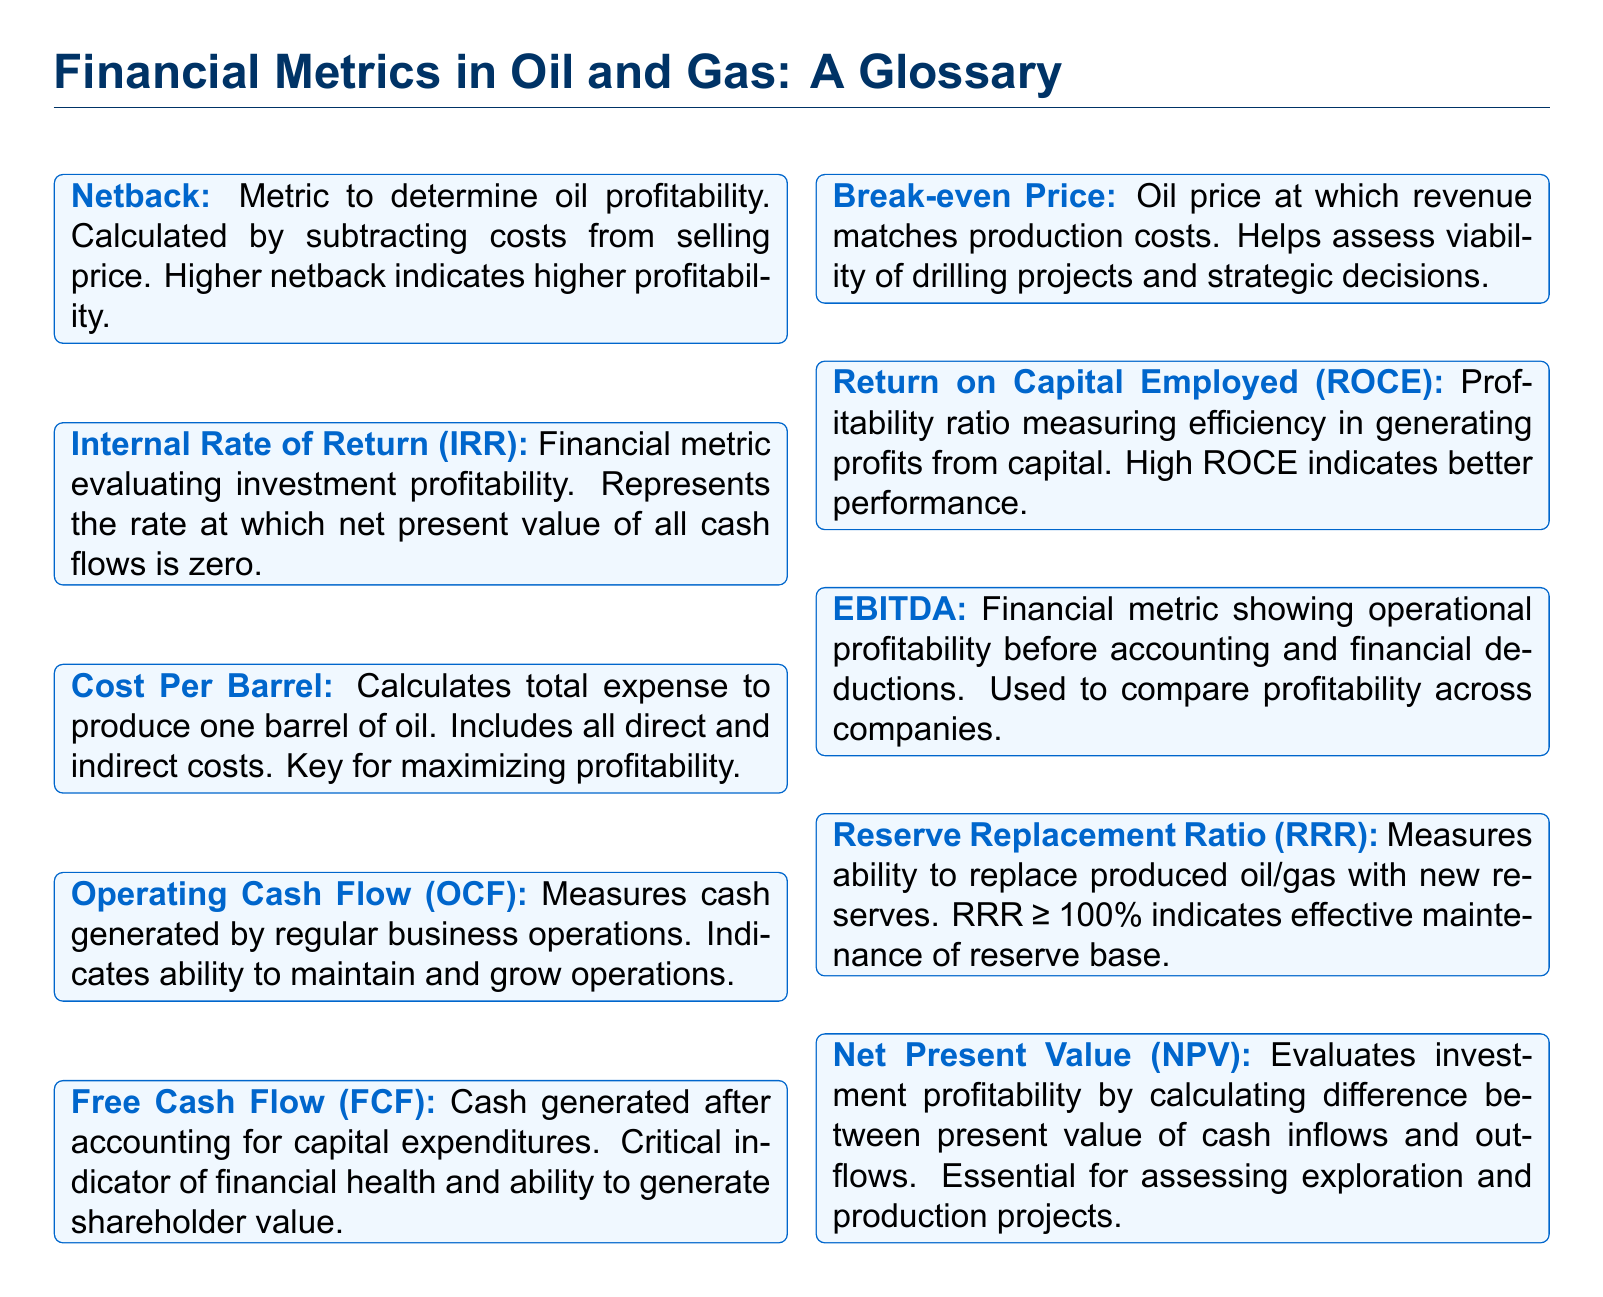What is Netback? Netback is a metric to determine oil profitability, calculated by subtracting costs from selling price.
Answer: A metric to determine oil profitability What does IRR stand for? IRR stands for Internal Rate of Return, a financial metric evaluating investment profitability.
Answer: Internal Rate of Return What does Cost Per Barrel refer to? Cost Per Barrel calculates the total expense to produce one barrel of oil, including all direct and indirect costs.
Answer: Total expense to produce one barrel of oil What is OCF? OCF stands for Operating Cash Flow, which measures cash generated by regular business operations.
Answer: Operating Cash Flow What does a RRR of 100% indicate? A Reserve Replacement Ratio (RRR) of 100% indicates effective maintenance of the reserve base.
Answer: Effective maintenance of reserve base What does EBITDA represent? EBITDA represents a financial metric showing operational profitability before accounting and financial deductions.
Answer: Operational profitability before deductions What is the purpose of the Break-even Price? The purpose of the Break-even Price is to determine the oil price at which revenue matches production costs.
Answer: To determine the oil price that matches production costs What does a high ROCE indicate? A high Return on Capital Employed (ROCE) indicates better performance in generating profits from capital.
Answer: Better performance in generating profits What is NPV used for? Net Present Value (NPV) is used to evaluate investment profitability by calculating the difference between present value of cash inflows and outflows.
Answer: Evaluating investment profitability 